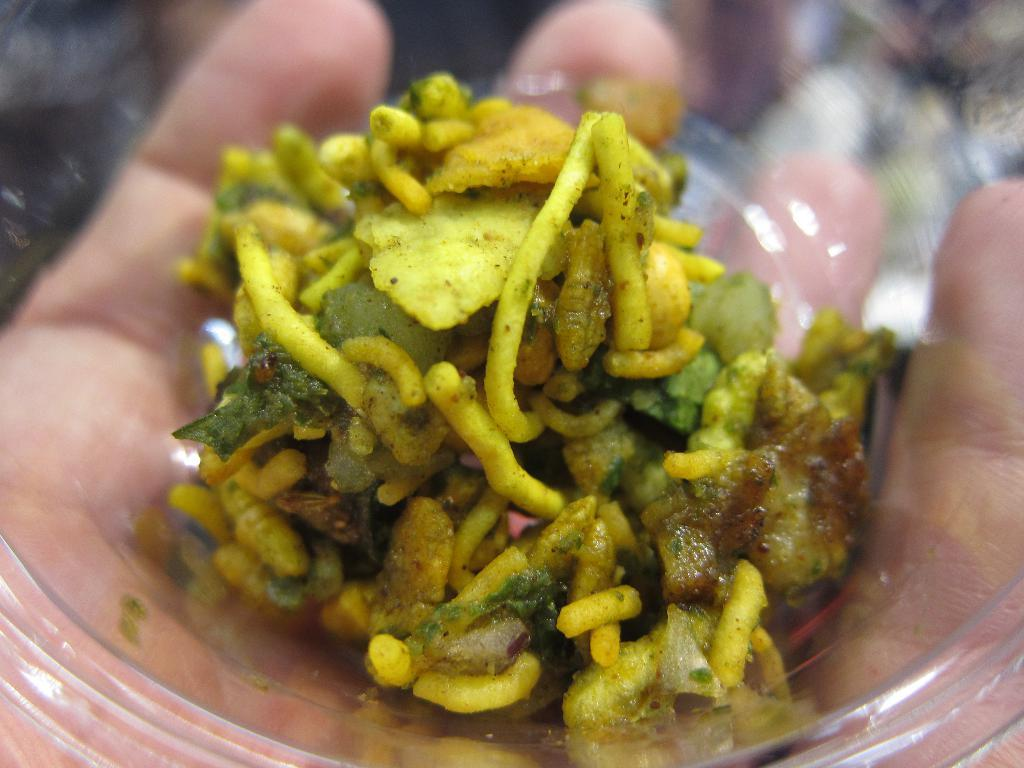What is in the bowl that is visible in the image? There is food placed in a bowl in the image. Who is holding the bowl in the image? A person is holding the bowl in the image. What type of card is being used to mix the liquid in the bowl? There is no card or liquid present in the image; it only features a bowl of food and a person holding it. 